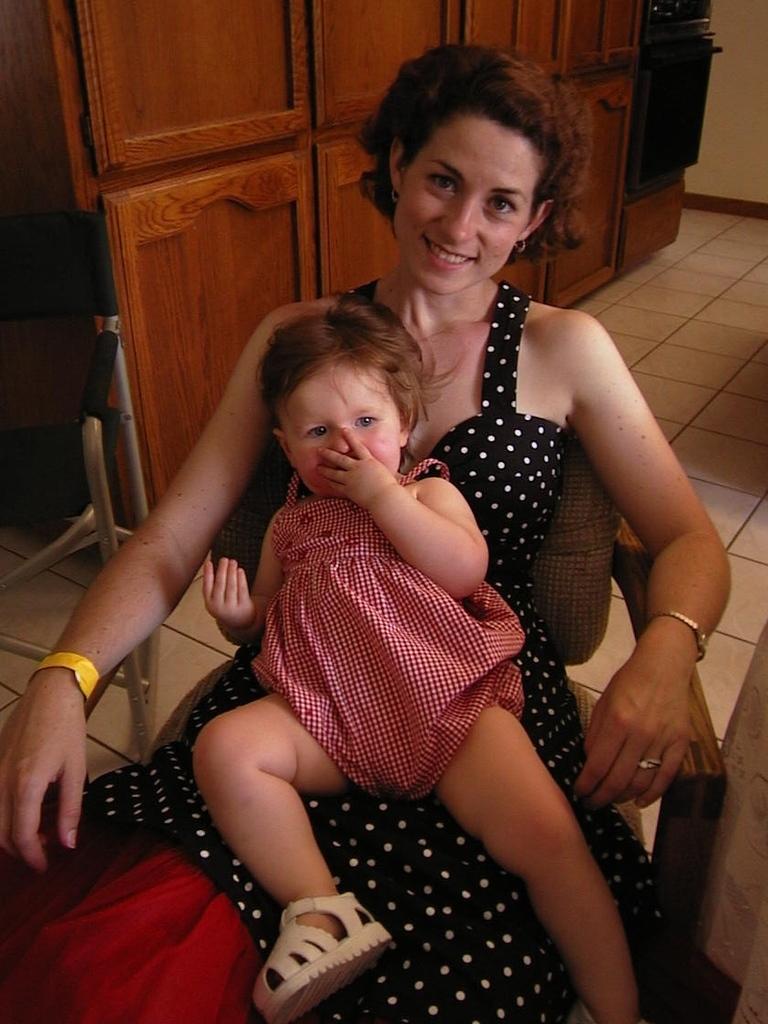How would you summarize this image in a sentence or two? In this image in the center there is one woman who is sitting and she is holding one baby, in the background there is a chair and a cupboard. At the bottom there is a floor. 